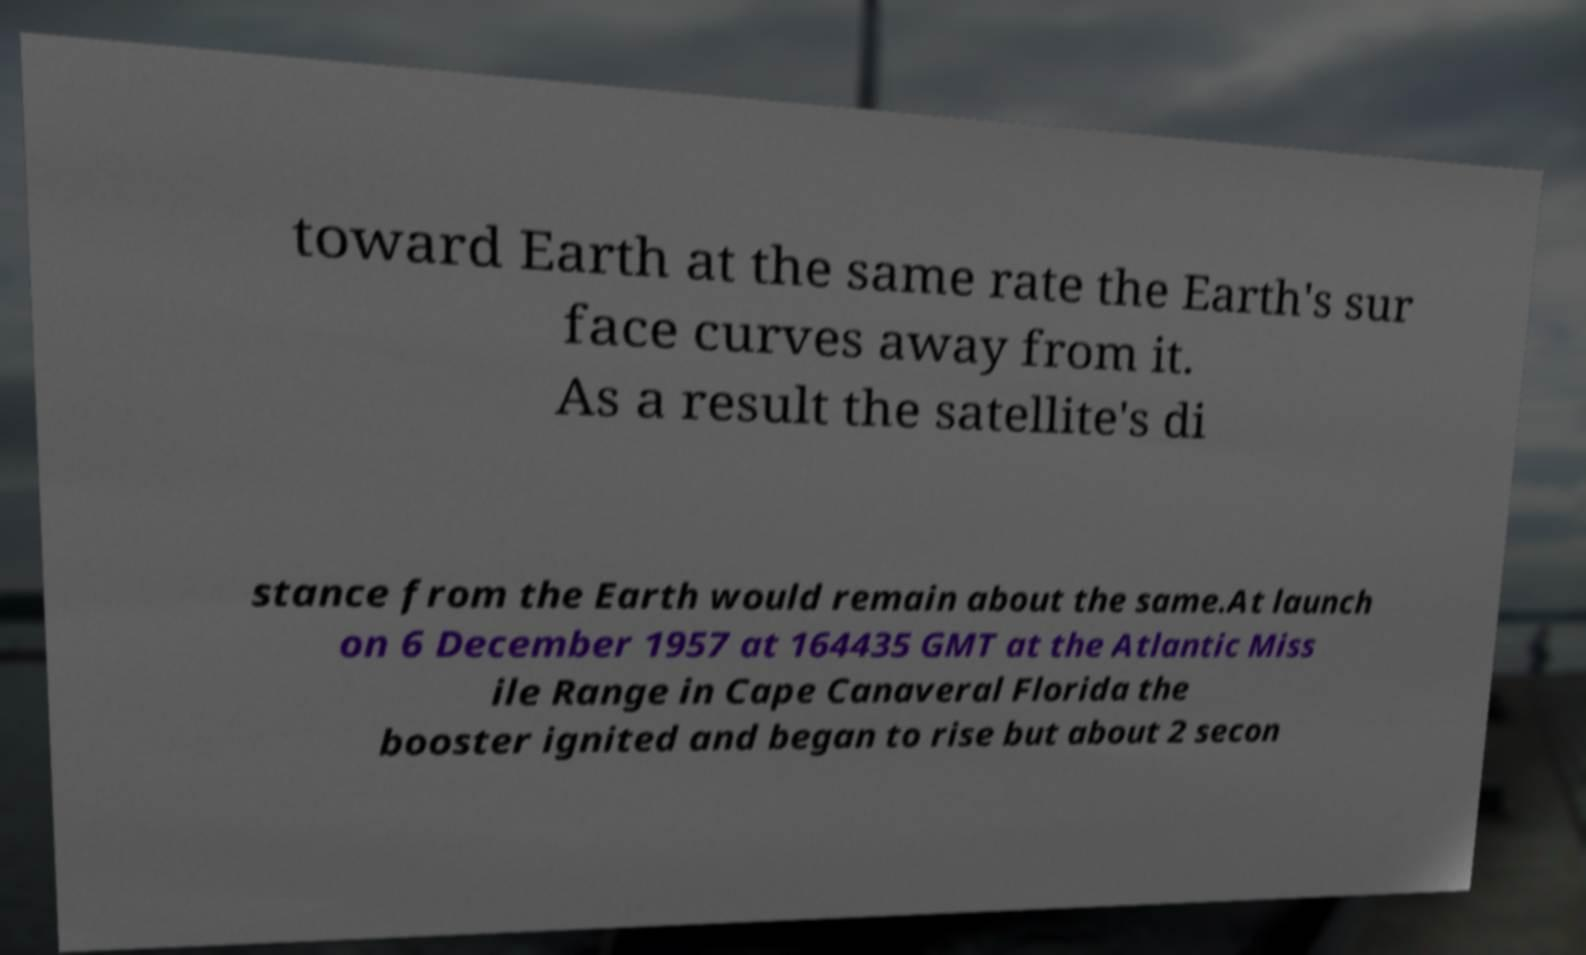Please read and relay the text visible in this image. What does it say? toward Earth at the same rate the Earth's sur face curves away from it. As a result the satellite's di stance from the Earth would remain about the same.At launch on 6 December 1957 at 164435 GMT at the Atlantic Miss ile Range in Cape Canaveral Florida the booster ignited and began to rise but about 2 secon 